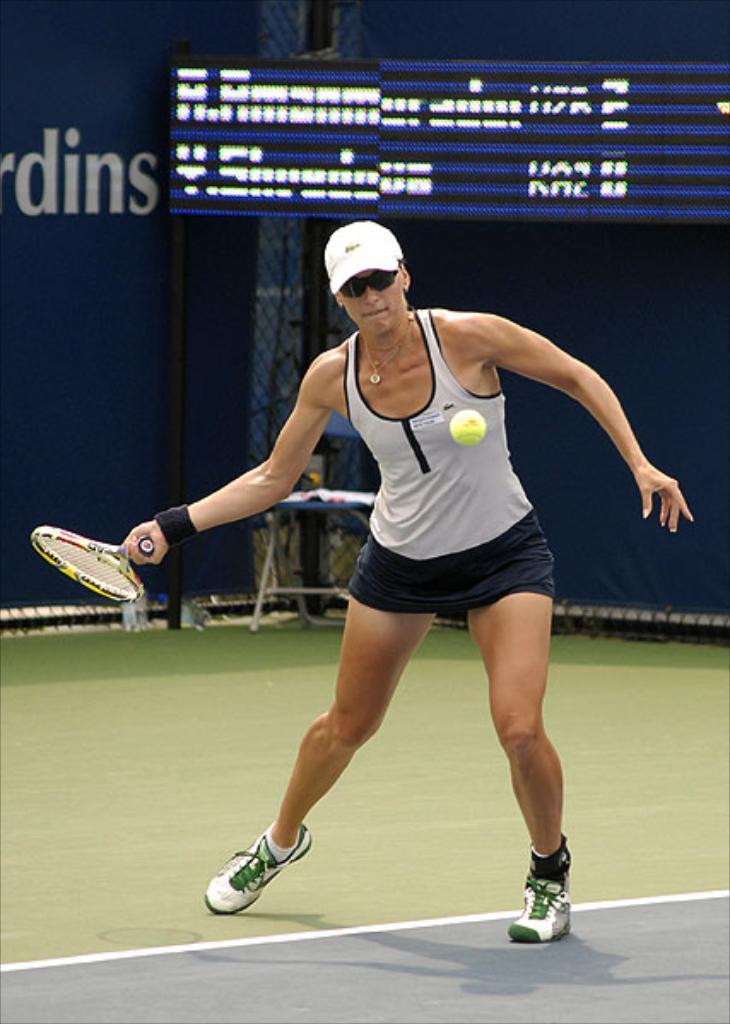Can you describe this image briefly? In this image picture women is playing a badminton in a court she is holding a bad background we can see the display. 